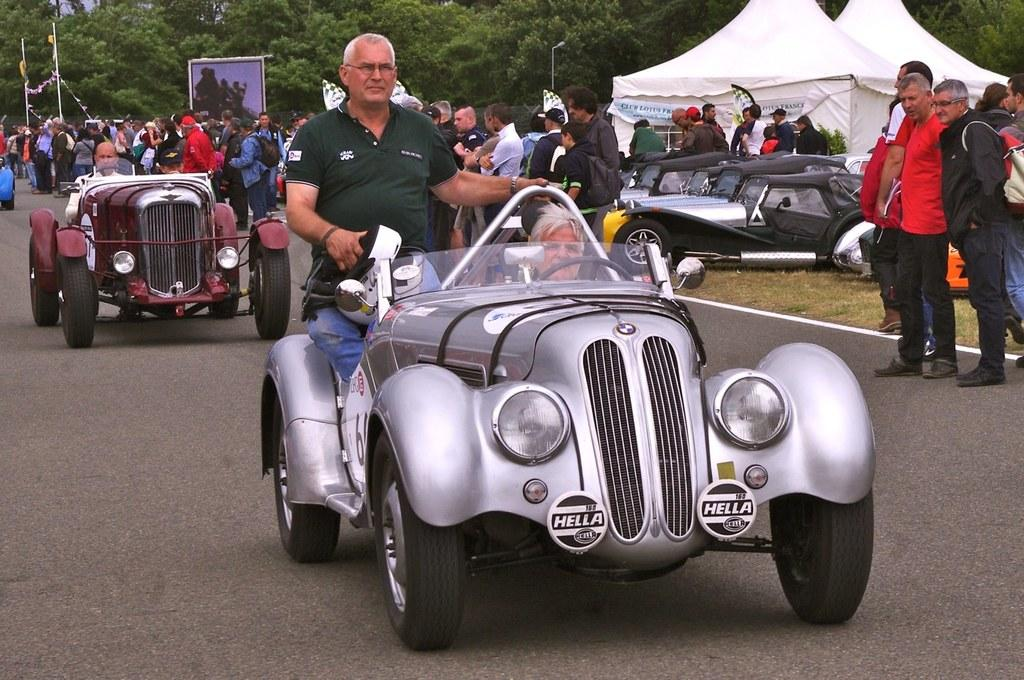What is the man doing in the image? The man is on a car in the image. Can you describe the position of the second car in relation to the first car? There is another car behind the first car in the image. What is the reaction of the people around the cars? There are many people looking at the cars on the road in the image. What type of credit can be seen on the canvas in the image? There is no canvas or credit present in the image. Who is the manager of the car in the image? There is no mention of a manager in the image. 